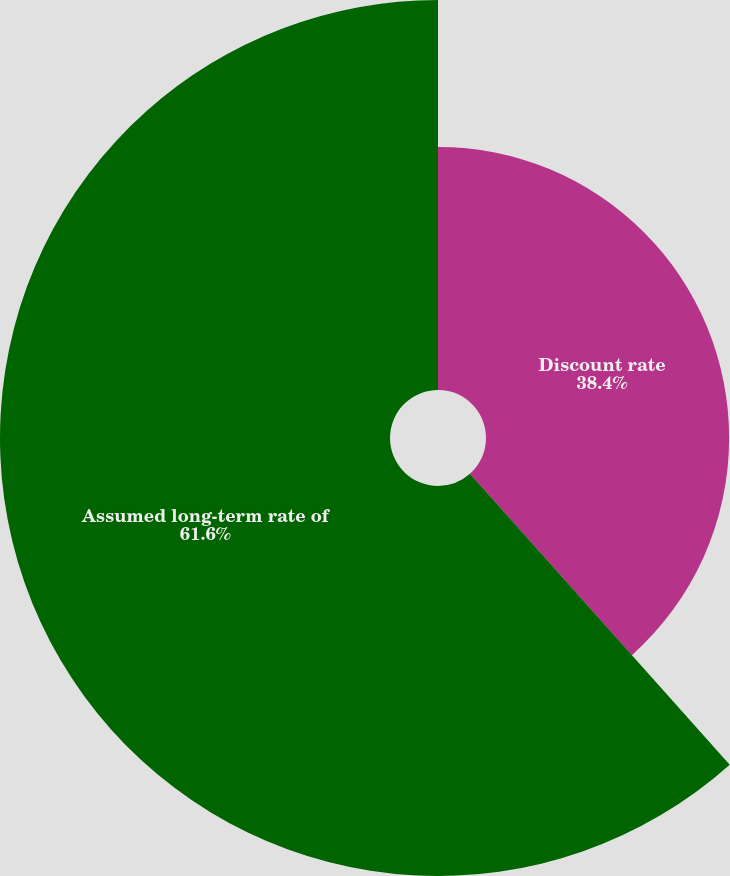Convert chart to OTSL. <chart><loc_0><loc_0><loc_500><loc_500><pie_chart><fcel>Discount rate<fcel>Assumed long-term rate of<nl><fcel>38.4%<fcel>61.6%<nl></chart> 